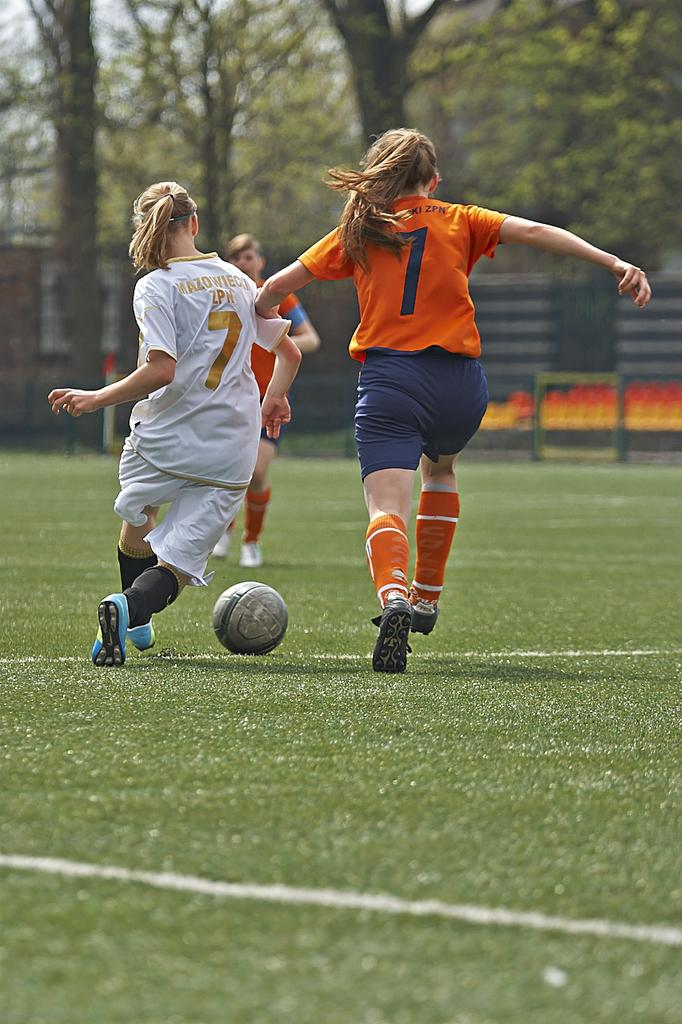What are the two women in the image doing? The two women in the image are running and appear to be playing a game. What object is associated with the game they are playing? There is a football in the image. Can you describe the person standing in the image? There is another person standing in the image, but their role or involvement in the game is not clear. What type of surface are the women running on? The ground is covered with grass. What can be seen in the background of the image? There are trees visible in the background of the image. What type of dress is the porter wearing in the image? There is no porter present in the image, and therefore no dress to describe. What is the engine used for in the image? There is no engine present in the image, so its purpose cannot be determined. 